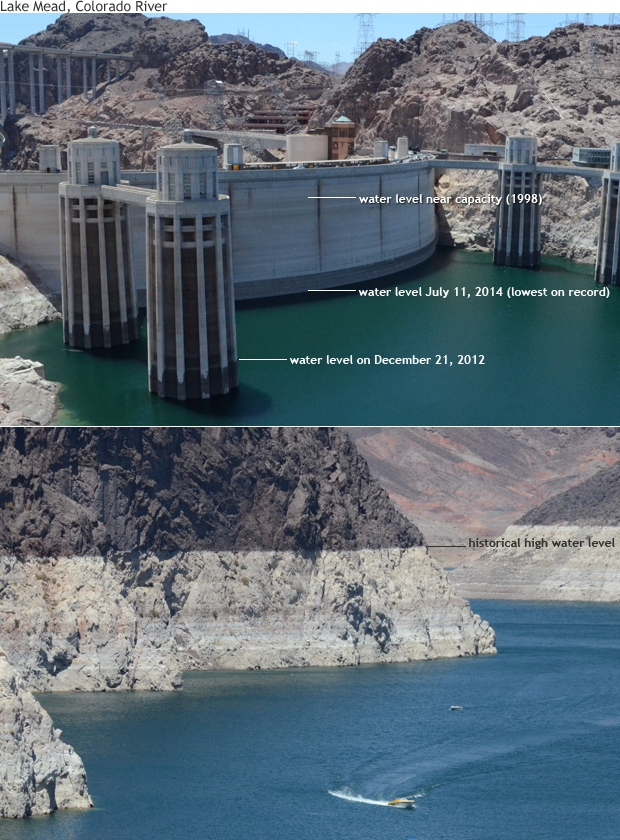Can you highlight the implications of prolonged droughts as seen in the image? Prolonged droughts, as highlighted by the receding water levels in the image of Lake Mead, have several significant implications. Economically, they can affect water supply for agriculture, leading to crop failures and food shortages. Environmentally, droughts can degrade ecosystems, reduce biodiversity, and lead to more frequent and severe wildfires. Socially, communities dependent on consistent water sources may face severe stress, potentially leading to displacement and conflicts over resources. These droughts also underscore the urgent need for sustainable water management and conservation practices to mitigate long-term impacts. What practical steps can local governments take to address these issues? Local governments can take several practical steps to address the issues arising from prolonged droughts and receding water levels. First, they can invest in water-saving technologies and infrastructure, such as efficient irrigation systems and water recycling plants. Second, implementing policies that promote sustainable water use, such as tiered water pricing and restrictions on non-essential water use, can encourage conservation. Third, engaging in public awareness campaigns can educate citizens about the importance of conserving water. Additionally, supporting research and development of drought-resistant crops and alternative water sources, like desalination, can provide long-term solutions. Collaborating with neighboring regions on water management and preparing robust contingency plans for extreme water shortages is also crucial. 